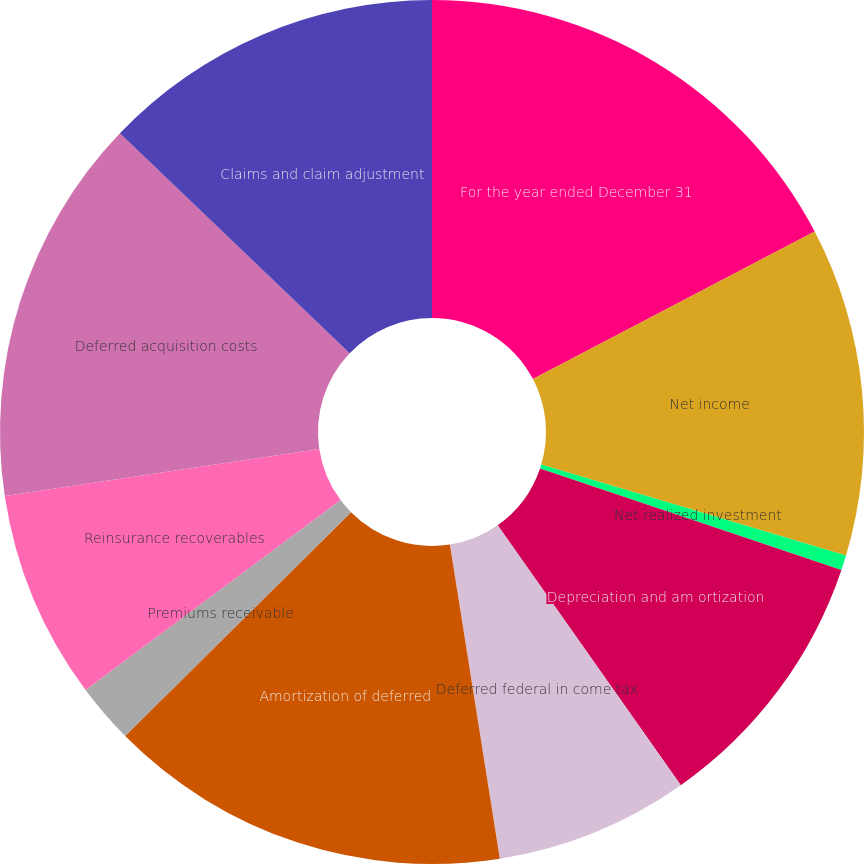Convert chart to OTSL. <chart><loc_0><loc_0><loc_500><loc_500><pie_chart><fcel>For the year ended December 31<fcel>Net income<fcel>Net realized investment<fcel>Depreciation and am ortization<fcel>Deferred federal in come tax<fcel>Amortization of deferred<fcel>Premiums receivable<fcel>Reinsurance recoverables<fcel>Deferred acquisition costs<fcel>Claims and claim adjustment<nl><fcel>17.32%<fcel>12.29%<fcel>0.56%<fcel>10.06%<fcel>7.26%<fcel>15.08%<fcel>2.24%<fcel>7.82%<fcel>14.52%<fcel>12.85%<nl></chart> 